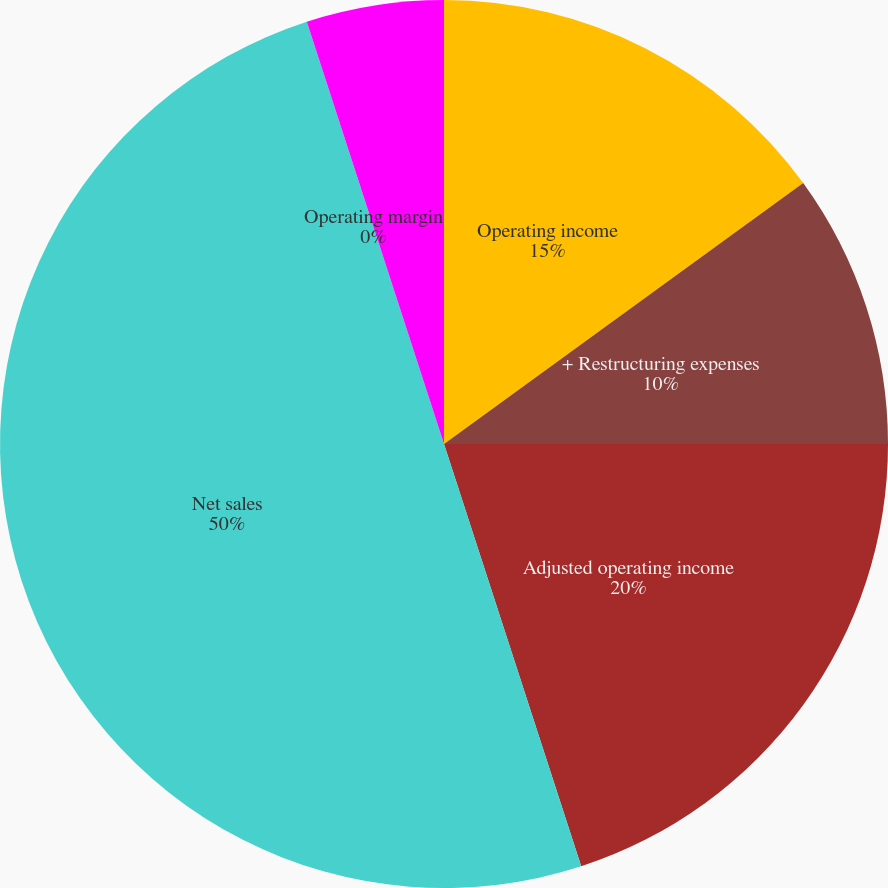Convert chart to OTSL. <chart><loc_0><loc_0><loc_500><loc_500><pie_chart><fcel>Operating income<fcel>+ Restructuring expenses<fcel>Adjusted operating income<fcel>Net sales<fcel>Operating margin<fcel>Adjusted operating margin<nl><fcel>15.0%<fcel>10.0%<fcel>20.0%<fcel>50.0%<fcel>0.0%<fcel>5.0%<nl></chart> 